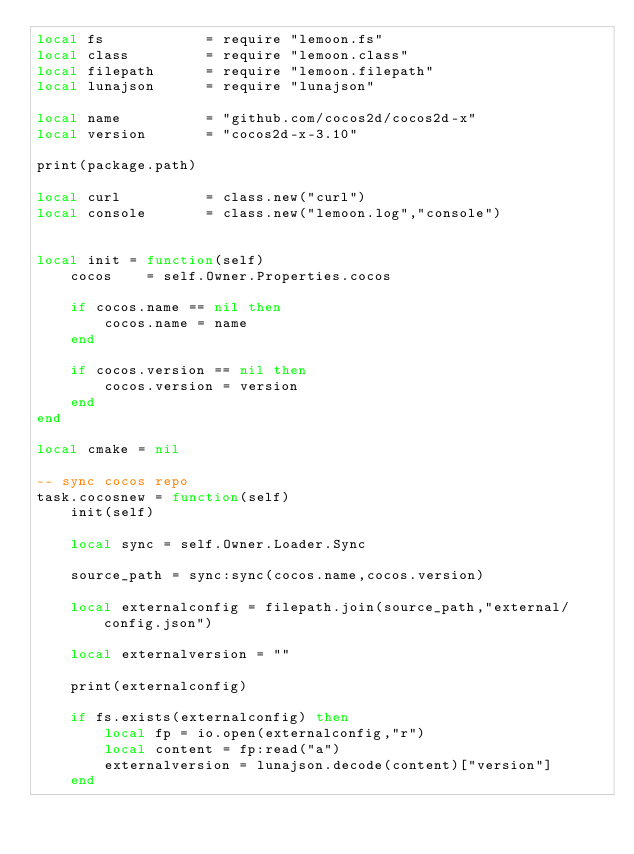Convert code to text. <code><loc_0><loc_0><loc_500><loc_500><_Lua_>local fs            = require "lemoon.fs"
local class         = require "lemoon.class"
local filepath      = require "lemoon.filepath"
local lunajson      = require "lunajson"

local name          = "github.com/cocos2d/cocos2d-x"
local version       = "cocos2d-x-3.10"

print(package.path)

local curl          = class.new("curl")
local console       = class.new("lemoon.log","console")


local init = function(self)
    cocos    = self.Owner.Properties.cocos

    if cocos.name == nil then
        cocos.name = name
    end

    if cocos.version == nil then
        cocos.version = version
    end
end

local cmake = nil

-- sync cocos repo
task.cocosnew = function(self)
    init(self)

    local sync = self.Owner.Loader.Sync

    source_path = sync:sync(cocos.name,cocos.version)

    local externalconfig = filepath.join(source_path,"external/config.json")

    local externalversion = ""

    print(externalconfig)

    if fs.exists(externalconfig) then
        local fp = io.open(externalconfig,"r")
        local content = fp:read("a")
        externalversion = lunajson.decode(content)["version"]
    end
</code> 